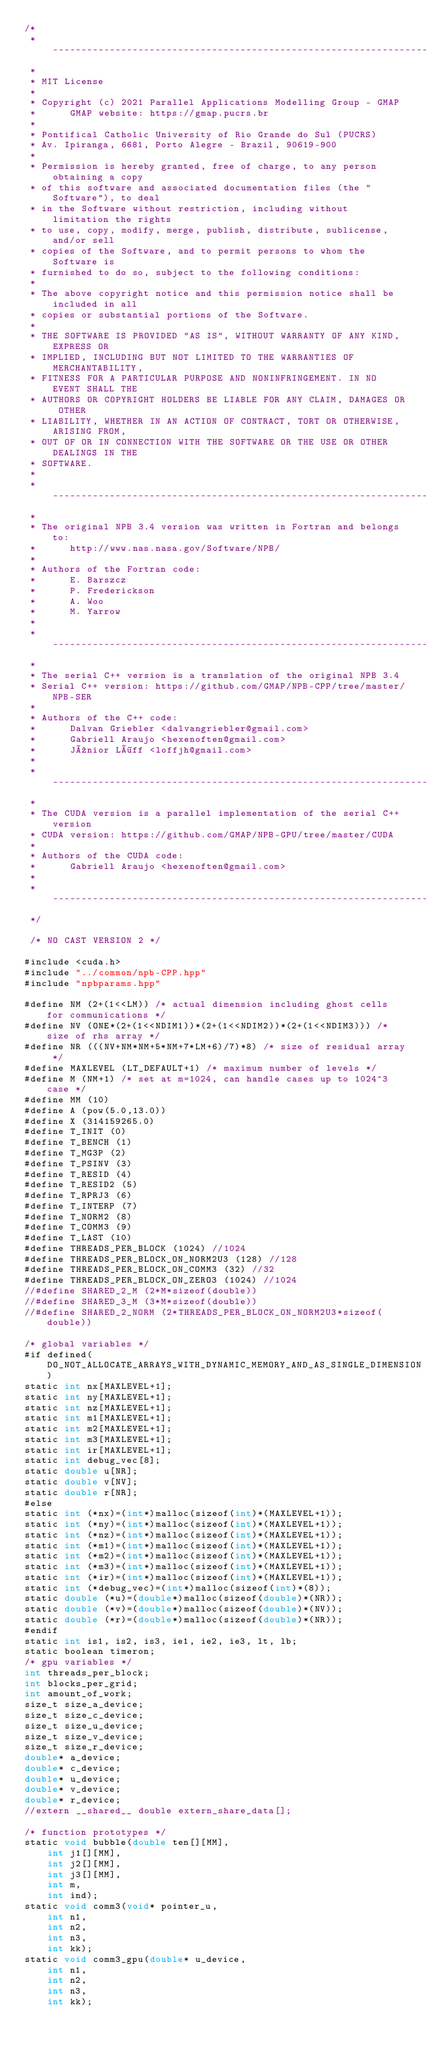<code> <loc_0><loc_0><loc_500><loc_500><_Cuda_>/* 
 * ------------------------------------------------------------------------------
 *
 * MIT License
 *
 * Copyright (c) 2021 Parallel Applications Modelling Group - GMAP
 *      GMAP website: https://gmap.pucrs.br
 *
 * Pontifical Catholic University of Rio Grande do Sul (PUCRS)
 * Av. Ipiranga, 6681, Porto Alegre - Brazil, 90619-900
 *
 * Permission is hereby granted, free of charge, to any person obtaining a copy
 * of this software and associated documentation files (the "Software"), to deal
 * in the Software without restriction, including without limitation the rights
 * to use, copy, modify, merge, publish, distribute, sublicense, and/or sell
 * copies of the Software, and to permit persons to whom the Software is
 * furnished to do so, subject to the following conditions:
 *
 * The above copyright notice and this permission notice shall be included in all
 * copies or substantial portions of the Software.
 *
 * THE SOFTWARE IS PROVIDED "AS IS", WITHOUT WARRANTY OF ANY KIND, EXPRESS OR
 * IMPLIED, INCLUDING BUT NOT LIMITED TO THE WARRANTIES OF MERCHANTABILITY,
 * FITNESS FOR A PARTICULAR PURPOSE AND NONINFRINGEMENT. IN NO EVENT SHALL THE
 * AUTHORS OR COPYRIGHT HOLDERS BE LIABLE FOR ANY CLAIM, DAMAGES OR OTHER
 * LIABILITY, WHETHER IN AN ACTION OF CONTRACT, TORT OR OTHERWISE, ARISING FROM,
 * OUT OF OR IN CONNECTION WITH THE SOFTWARE OR THE USE OR OTHER DEALINGS IN THE
 * SOFTWARE.
 *
 * ------------------------------------------------------------------------------
 *
 * The original NPB 3.4 version was written in Fortran and belongs to:
 *      http://www.nas.nasa.gov/Software/NPB/
 *
 * Authors of the Fortran code:
 *      E. Barszcz
 *      P. Frederickson
 *      A. Woo
 *      M. Yarrow
 *
 * ------------------------------------------------------------------------------
 *
 * The serial C++ version is a translation of the original NPB 3.4
 * Serial C++ version: https://github.com/GMAP/NPB-CPP/tree/master/NPB-SER
 *
 * Authors of the C++ code:
 *      Dalvan Griebler <dalvangriebler@gmail.com>
 *      Gabriell Araujo <hexenoften@gmail.com>
 *      Júnior Löff <loffjh@gmail.com>
 *
 * ------------------------------------------------------------------------------
 *
 * The CUDA version is a parallel implementation of the serial C++ version
 * CUDA version: https://github.com/GMAP/NPB-GPU/tree/master/CUDA
 *
 * Authors of the CUDA code:
 *      Gabriell Araujo <hexenoften@gmail.com>
 *
 * ------------------------------------------------------------------------------
 */

 /* NO CAST VERSION 2 */

#include <cuda.h>
#include "../common/npb-CPP.hpp"
#include "npbparams.hpp"

#define NM (2+(1<<LM)) /* actual dimension including ghost cells for communications */
#define NV (ONE*(2+(1<<NDIM1))*(2+(1<<NDIM2))*(2+(1<<NDIM3))) /* size of rhs array */
#define NR (((NV+NM*NM+5*NM+7*LM+6)/7)*8) /* size of residual array */
#define MAXLEVEL (LT_DEFAULT+1) /* maximum number of levels */
#define M (NM+1) /* set at m=1024, can handle cases up to 1024^3 case */
#define MM (10)
#define	A (pow(5.0,13.0))
#define	X (314159265.0)
#define T_INIT (0)
#define T_BENCH (1)
#define T_MG3P (2)
#define T_PSINV (3)
#define T_RESID (4)
#define T_RESID2 (5)
#define T_RPRJ3 (6)
#define T_INTERP (7)
#define T_NORM2 (8)
#define T_COMM3 (9)
#define T_LAST (10)
#define THREADS_PER_BLOCK (1024) //1024
#define THREADS_PER_BLOCK_ON_NORM2U3 (128) //128
#define THREADS_PER_BLOCK_ON_COMM3 (32) //32
#define THREADS_PER_BLOCK_ON_ZERO3 (1024) //1024
//#define SHARED_2_M (2*M*sizeof(double))
//#define SHARED_3_M (3*M*sizeof(double))
//#define SHARED_2_NORM (2*THREADS_PER_BLOCK_ON_NORM2U3*sizeof(double))

/* global variables */
#if defined(DO_NOT_ALLOCATE_ARRAYS_WITH_DYNAMIC_MEMORY_AND_AS_SINGLE_DIMENSION)
static int nx[MAXLEVEL+1];
static int ny[MAXLEVEL+1];
static int nz[MAXLEVEL+1];
static int m1[MAXLEVEL+1];
static int m2[MAXLEVEL+1];
static int m3[MAXLEVEL+1];
static int ir[MAXLEVEL+1];
static int debug_vec[8];
static double u[NR];
static double v[NV];
static double r[NR];
#else
static int (*nx)=(int*)malloc(sizeof(int)*(MAXLEVEL+1));
static int (*ny)=(int*)malloc(sizeof(int)*(MAXLEVEL+1));
static int (*nz)=(int*)malloc(sizeof(int)*(MAXLEVEL+1));
static int (*m1)=(int*)malloc(sizeof(int)*(MAXLEVEL+1));
static int (*m2)=(int*)malloc(sizeof(int)*(MAXLEVEL+1));
static int (*m3)=(int*)malloc(sizeof(int)*(MAXLEVEL+1));
static int (*ir)=(int*)malloc(sizeof(int)*(MAXLEVEL+1));
static int (*debug_vec)=(int*)malloc(sizeof(int)*(8));
static double (*u)=(double*)malloc(sizeof(double)*(NR));
static double (*v)=(double*)malloc(sizeof(double)*(NV));
static double (*r)=(double*)malloc(sizeof(double)*(NR));
#endif
static int is1, is2, is3, ie1, ie2, ie3, lt, lb;
static boolean timeron;
/* gpu variables */
int threads_per_block;
int blocks_per_grid;
int amount_of_work;
size_t size_a_device;
size_t size_c_device;
size_t size_u_device;
size_t size_v_device;
size_t size_r_device;
double* a_device;
double* c_device;
double* u_device;
double* v_device;
double* r_device;
//extern __shared__ double extern_share_data[];

/* function prototypes */
static void bubble(double ten[][MM], 
		int j1[][MM], 
		int j2[][MM], 
		int j3[][MM], 
		int m, 
		int ind);
static void comm3(void* pointer_u, 
		int n1, 
		int n2, 
		int n3, 
		int kk);
static void comm3_gpu(double* u_device, 
		int n1, 
		int n2, 
		int n3, 
		int kk);</code> 